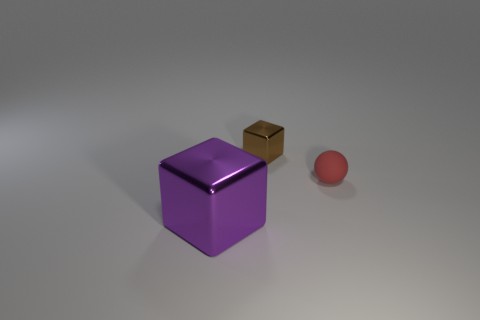What could be the possible functions of these objects if they were real? Given their simplistic shapes and lack of additional context, it's difficult to ascribe specific functions. However, one could imagine the cube being a container or decorative item, the smaller brown cube could be a paperweight or a die, and the sphere may serve as a ball for various games or a simple decoration. 